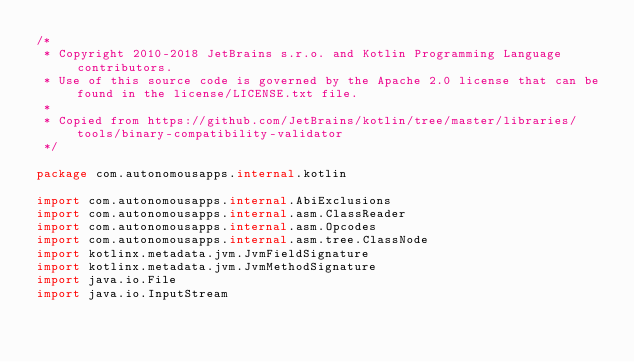Convert code to text. <code><loc_0><loc_0><loc_500><loc_500><_Kotlin_>/*
 * Copyright 2010-2018 JetBrains s.r.o. and Kotlin Programming Language contributors.
 * Use of this source code is governed by the Apache 2.0 license that can be found in the license/LICENSE.txt file.
 *
 * Copied from https://github.com/JetBrains/kotlin/tree/master/libraries/tools/binary-compatibility-validator
 */

package com.autonomousapps.internal.kotlin

import com.autonomousapps.internal.AbiExclusions
import com.autonomousapps.internal.asm.ClassReader
import com.autonomousapps.internal.asm.Opcodes
import com.autonomousapps.internal.asm.tree.ClassNode
import kotlinx.metadata.jvm.JvmFieldSignature
import kotlinx.metadata.jvm.JvmMethodSignature
import java.io.File
import java.io.InputStream</code> 